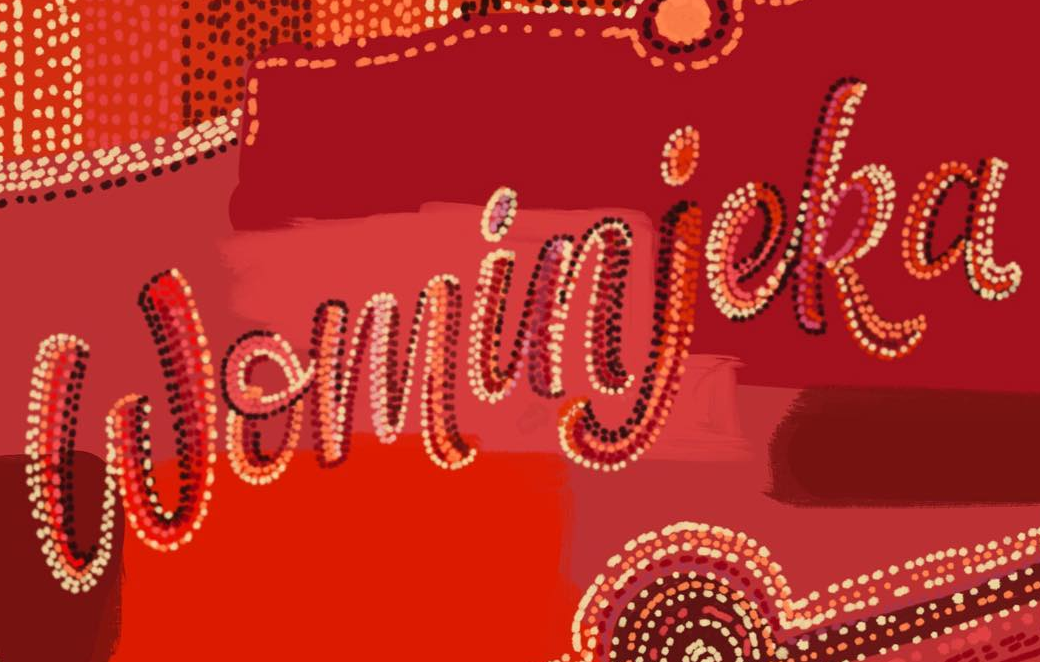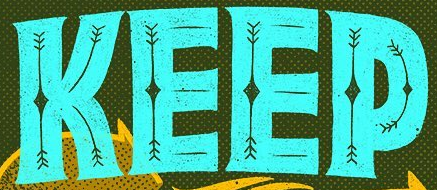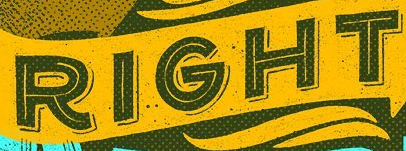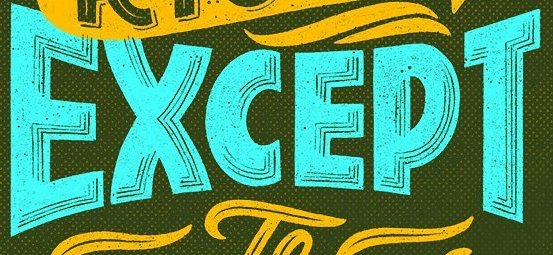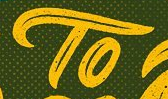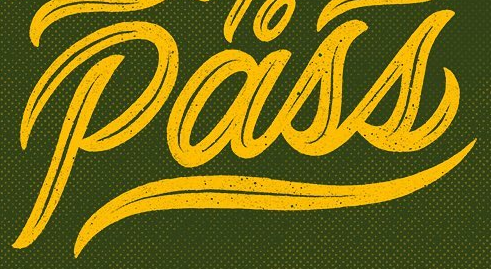Read the text from these images in sequence, separated by a semicolon. Wominjeka; KEEP; RIGHT; EXCEPT; TO; Pass 